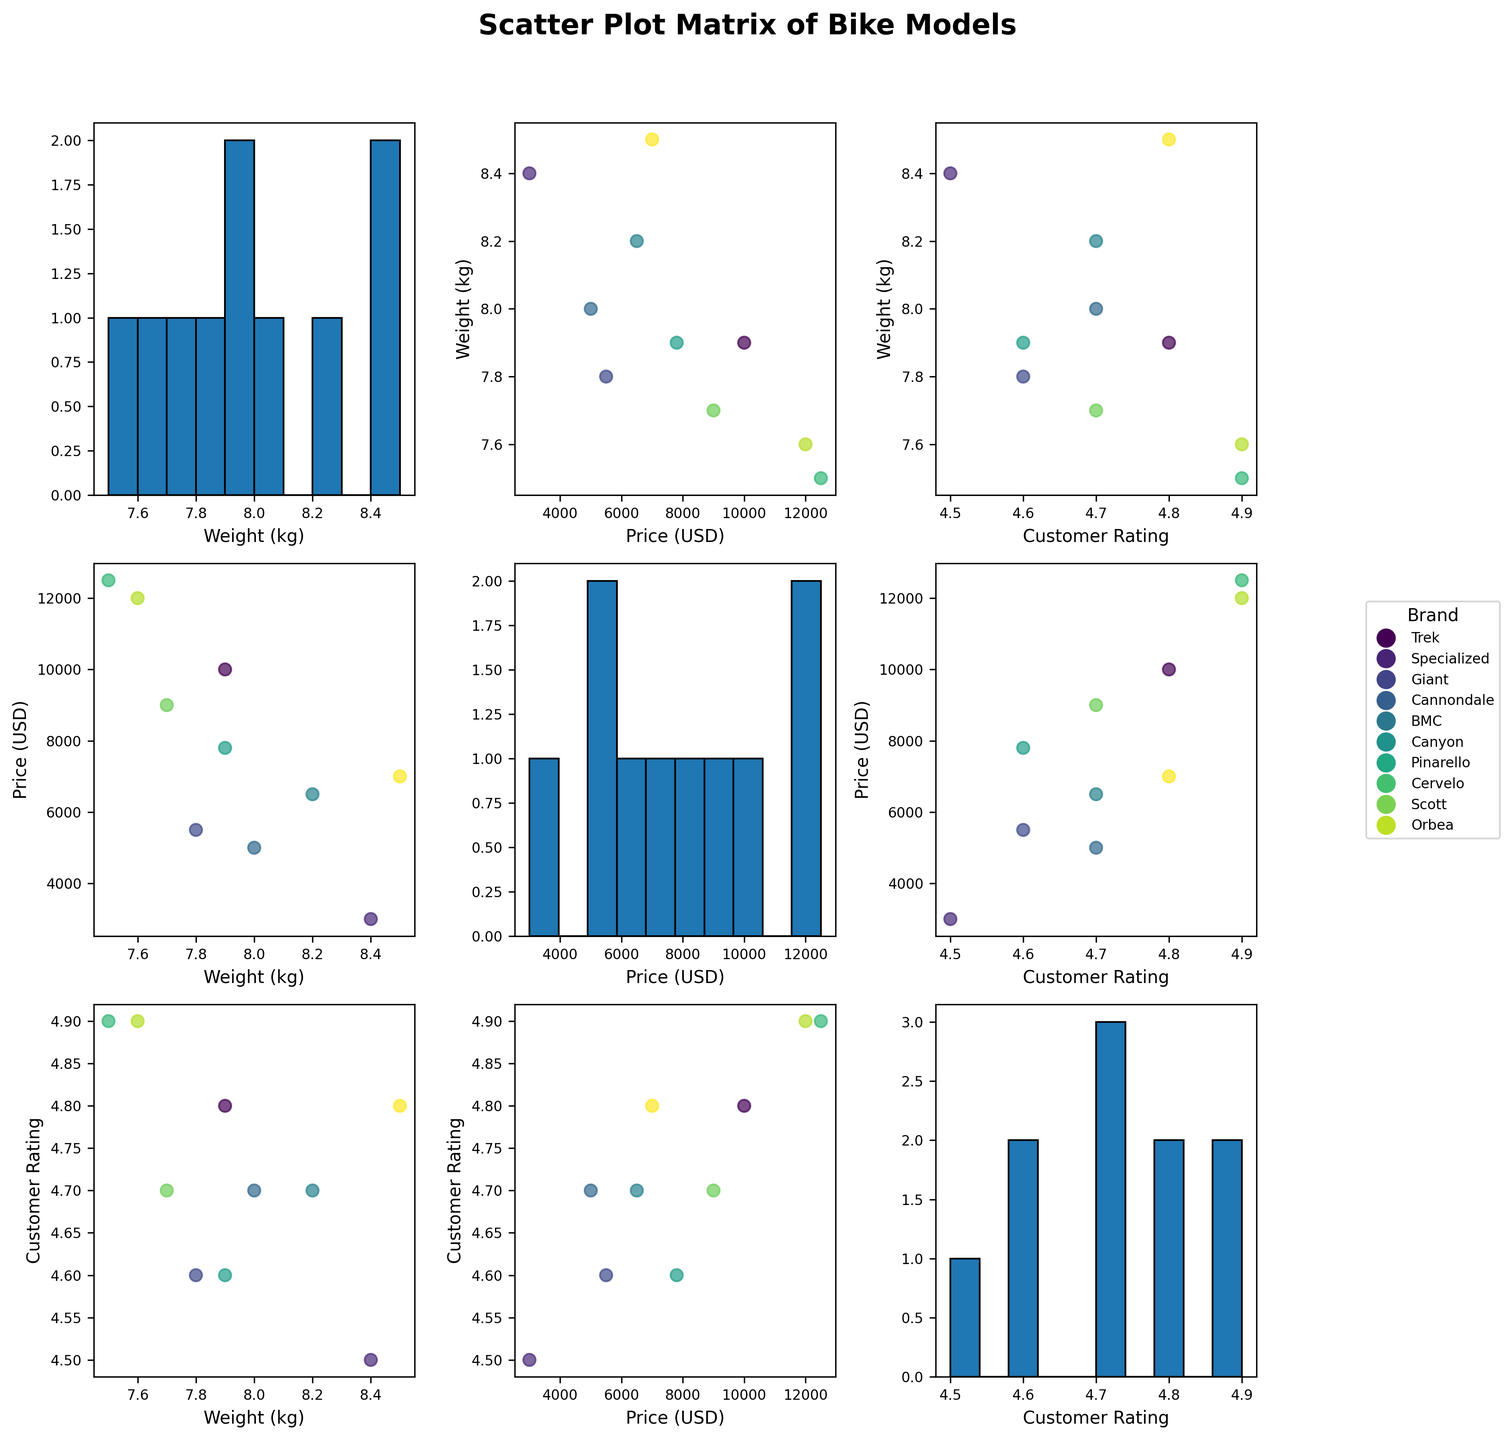What is the main title of the figure? The main title is displayed at the top of the SPLOM. By looking at the figure's top section, you can read the title directly.
Answer: Scatter Plot Matrix of Bike Models How many brands of bikes are represented in the figure? The legend on the right side of the figure lists all the brands, each associated with a different color. By counting the entries in the legend, we can determine the number of brands.
Answer: 10 Which brand is represented by the color used for the Domane SL 7 model? By checking the color of the points in the scatter plots or histograms corresponding to the Domane SL 7 model (Trek) and matching it to the color in the legend, we can identify the brand.
Answer: Trek Which axis represents Customer Rating in the SPLOM? Each axis is labeled with a variable name. By looking at the axes, we can identify that "Customer Rating" appears on both horizontal and vertical axes in different subplots.
Answer: Both horizontal and vertical axes in corresponding subplots What's the relationship between bike weight and customer rating? By examining the scatter plots where "Weight (kg)" and "Customer Rating" intersect, you can observe any visible trends.
Answer: No clear trend Which bike model has the lowest weight and what is its weight? By looking at the histograms of "Weight (kg)," identifying the lowest value, and cross-referencing with scatter plots to find the corresponding model, we determine that the Pinarello Dogma F12 has the lowest weight.
Answer: Dogma F12, 7.5 kg Are more expensive bikes rated higher by customers? By examining the scatter plots of "Price (USD)" versus "Customer Rating," we can notice if there's a trend where higher-priced bikes are clustered with higher customer ratings.
Answer: Generally, yes Which bike model has the highest customer rating and what is the rating? By inspecting the scatter plots and looking for the highest customer rating value (4.9), and cross-referencing with the corresponding bike models, we can determine that it applies to the Specialized Tarmac SL7 and Pinarello Dogma F12.
Answer: Tarmac SL7 and Dogma F12, 4.9 Do lighter bikes tend to be more expensive? By observing the scatter plots where "Weight (kg)" and "Price (USD)" intersect, looking for a pattern that lighter bikes are to the right (higher prices), we find that lighter bikes do tend to be more expensive.
Answer: Yes 